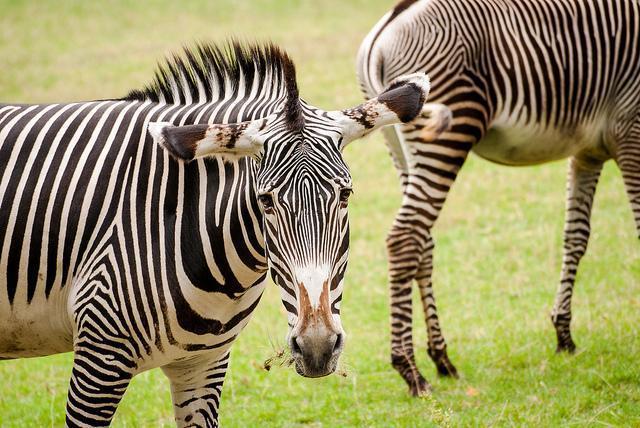How many zebras are in the photo?
Give a very brief answer. 2. 